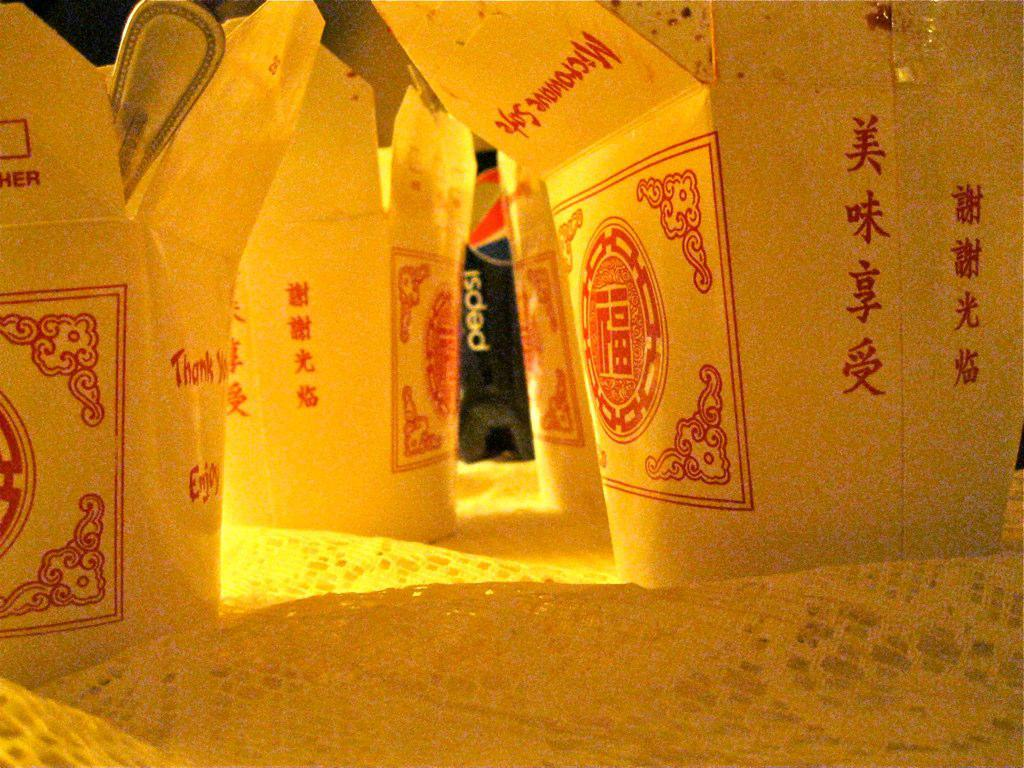Provide a one-sentence caption for the provided image. Various food boxes that are labeled microwave safe. 